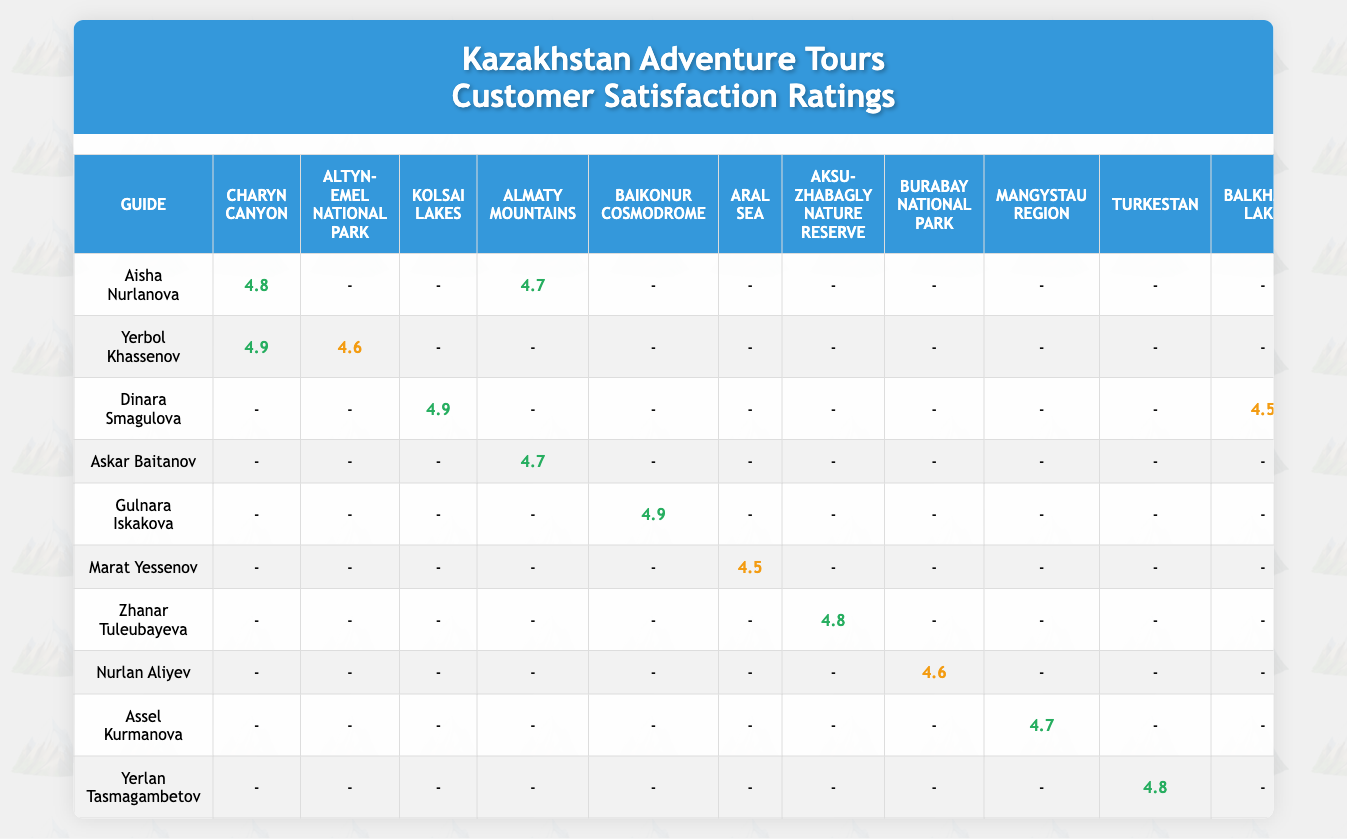What is the customer satisfaction rating for Dinara Smagulova's tour at Kolsai Lakes? According to the table, Dinara Smagulova's customer satisfaction rating for the Kolsai Lakes tour is 4.9.
Answer: 4.9 Who has the highest customer satisfaction rating for Charyn Canyon? The table shows that Yerbol Khassenov has the highest customer satisfaction rating for Charyn Canyon, which is 4.9.
Answer: 4.9 What is the average customer satisfaction rating for all guides who conducted tours in Almaty Mountains? The guides for Almaty Mountains are Askar Baitanov (4.7) and Aisha Nurlanova (4.7). Adding these ratings gives 4.7 + 4.7 = 9.4. Dividing by the number of tours (2) gives an average of 9.4 / 2 = 4.7.
Answer: 4.7 Did Gulnara Iskakova conduct any tours with a customer satisfaction rating below 4.5? Checking the table shows that Gulnara Iskakova has ratings of 4.9 for Baikonur Cosmodrome and 4.6 for Korgalzhyn State Nature Reserve, both of which are above 4.5.
Answer: No Which guide has the lowest average rating across tours? The guides with ratings to consider are Marat Yessenov (4.5), Nurlan Aliyev (4.6), and others. By checking every rating associated with each guide, Marat Yessenov has the lowest rating of 4.5 across his tours.
Answer: Marat Yessenov What is the total number of tours conducted by Aisha Nurlanova and what is her average customer satisfaction rating? Aisha Nurlanova conducted two tours: one at Charyn Canyon (4.8) and one at Almaty Mountains (4.7). The sum is 4.8 + 4.7 = 9.5, and dividing by 2 (the number of tours) gives an average of 4.75.
Answer: 2 tours, 4.75 average rating Which guide had the highest number of group size across their tours? Looking at the group sizes in the table, Gulnara Iskakova conducted a tour with a group size of 10 at Baikonur Cosmodrome, which is the highest listed.
Answer: Gulnara Iskakova Are there any guides rated above 4.8 who conducted tours in Kolsai Lakes or Altyn-Emel National Park? The table indicates that Dinara Smagulova scored 4.9 for Kolsai Lakes, which is above 4.8. However, no guide has a score above 4.8 for Altyn-Emel National Park since the highest rating there is 4.6 achieved by Yerbol Khassenov.
Answer: Yes for Kolsai Lakes, No for Altyn-Emel National Park 